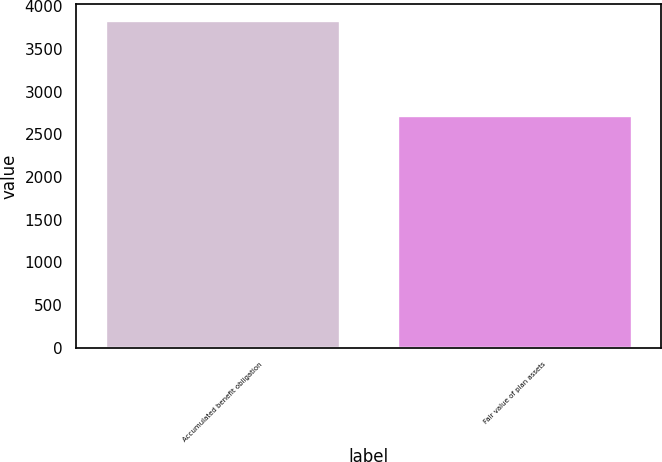<chart> <loc_0><loc_0><loc_500><loc_500><bar_chart><fcel>Accumulated benefit obligation<fcel>Fair value of plan assets<nl><fcel>3833<fcel>2713<nl></chart> 